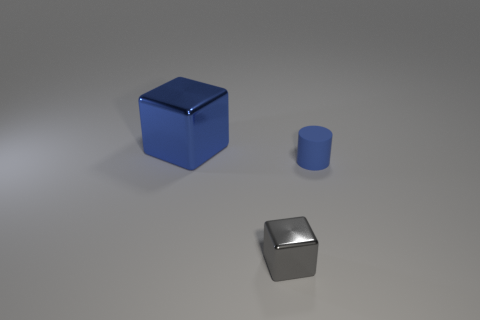What might be the purpose of these objects, considering their shape and colors? These objects, with their geometric shapes and distinct colors, might be components of a visual composition used for graphic design or 3D modeling practices. They could serve educational purposes to demonstrate principles of physics like light reflection or to exemplify geometric forms. They may also be part of a toy set for building and creative exploration. 